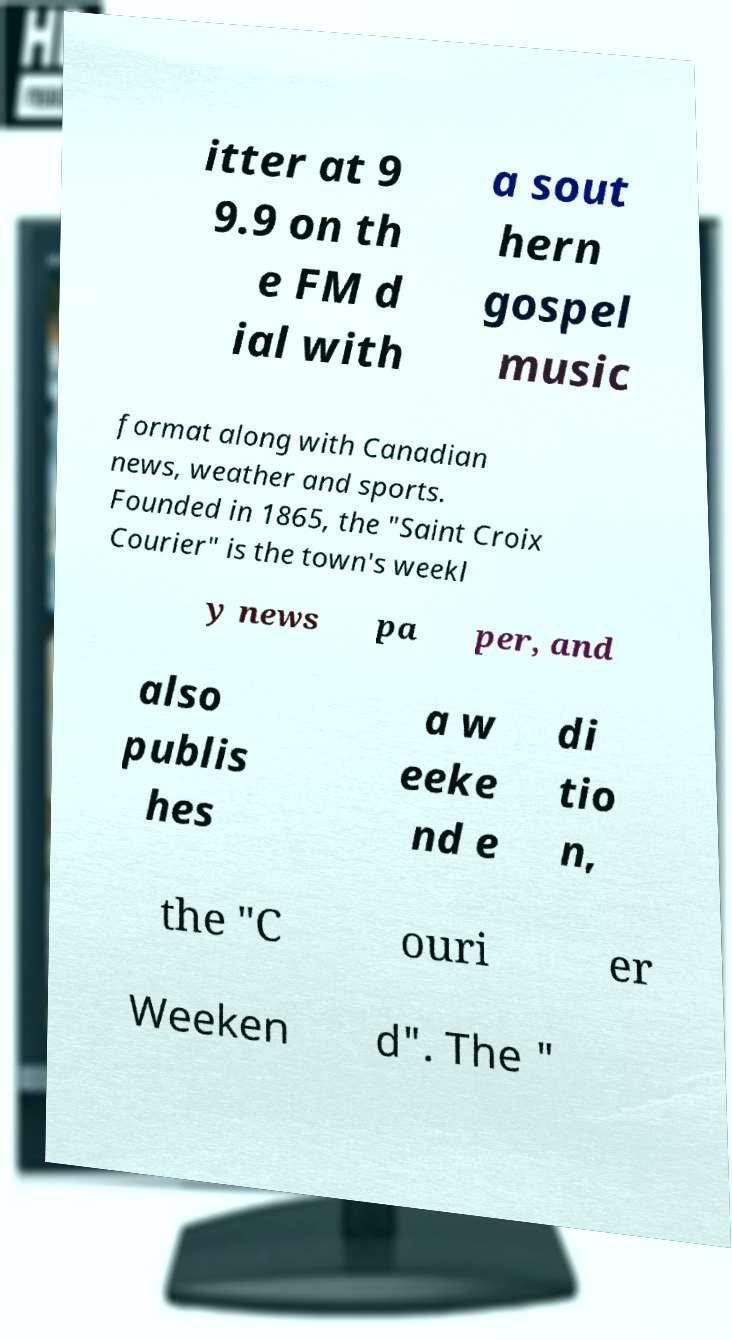Please read and relay the text visible in this image. What does it say? itter at 9 9.9 on th e FM d ial with a sout hern gospel music format along with Canadian news, weather and sports. Founded in 1865, the "Saint Croix Courier" is the town's weekl y news pa per, and also publis hes a w eeke nd e di tio n, the "C ouri er Weeken d". The " 